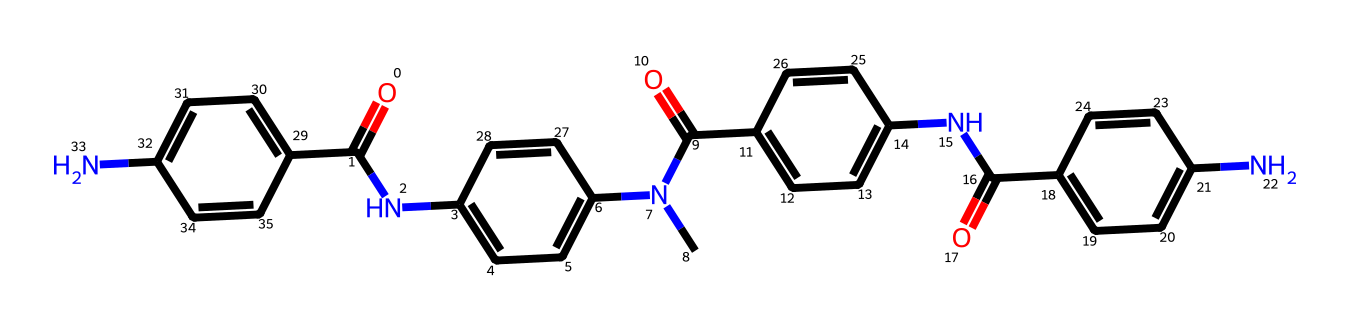What is the total number of nitrogen atoms in this compound? By analyzing the SMILES representation, count the nitrogen (N) symbols. There are four occurrences of nitrogen within this chemical structure.
Answer: 4 How many aromatic rings are present in the structure? Inspect the structure for benzene rings, which are characterized by alternating double bonds. The representation shows four distinct aromatic rings indicated by 'c' within a ring structure.
Answer: 4 Which functional group is primarily responsible for the flame-resistant properties of this fiber? The presence of amide (–C(=O)N–) groups contribute to the thermal stability and flame-resistant characteristics, seen through multiple amide linkages in the structure.
Answer: amide What is the molecular formula determined from the structure? Analyze each atom represented in the SMILES: Count the numbers of carbon (C), hydrogen (H), nitrogen (N), and oxygen (O). After counting, the molecular formula is deduced as C20H24N4O5.
Answer: C20H24N4O5 What type of polymer is this compound classified as? Given the repeating units formed by amide linkages and aromatic components, this compound is categorized as an aramid fiber, which is essential in high-performance textiles.
Answer: aramid fiber What is the significance of the amine groups in the chemical structure? Amine groups (–NH2) within the structure enhance the chemical's reactivity and bonding capabilities, which is crucial for improving fiber resilience and integrative properties in textile applications.
Answer: reactivity 